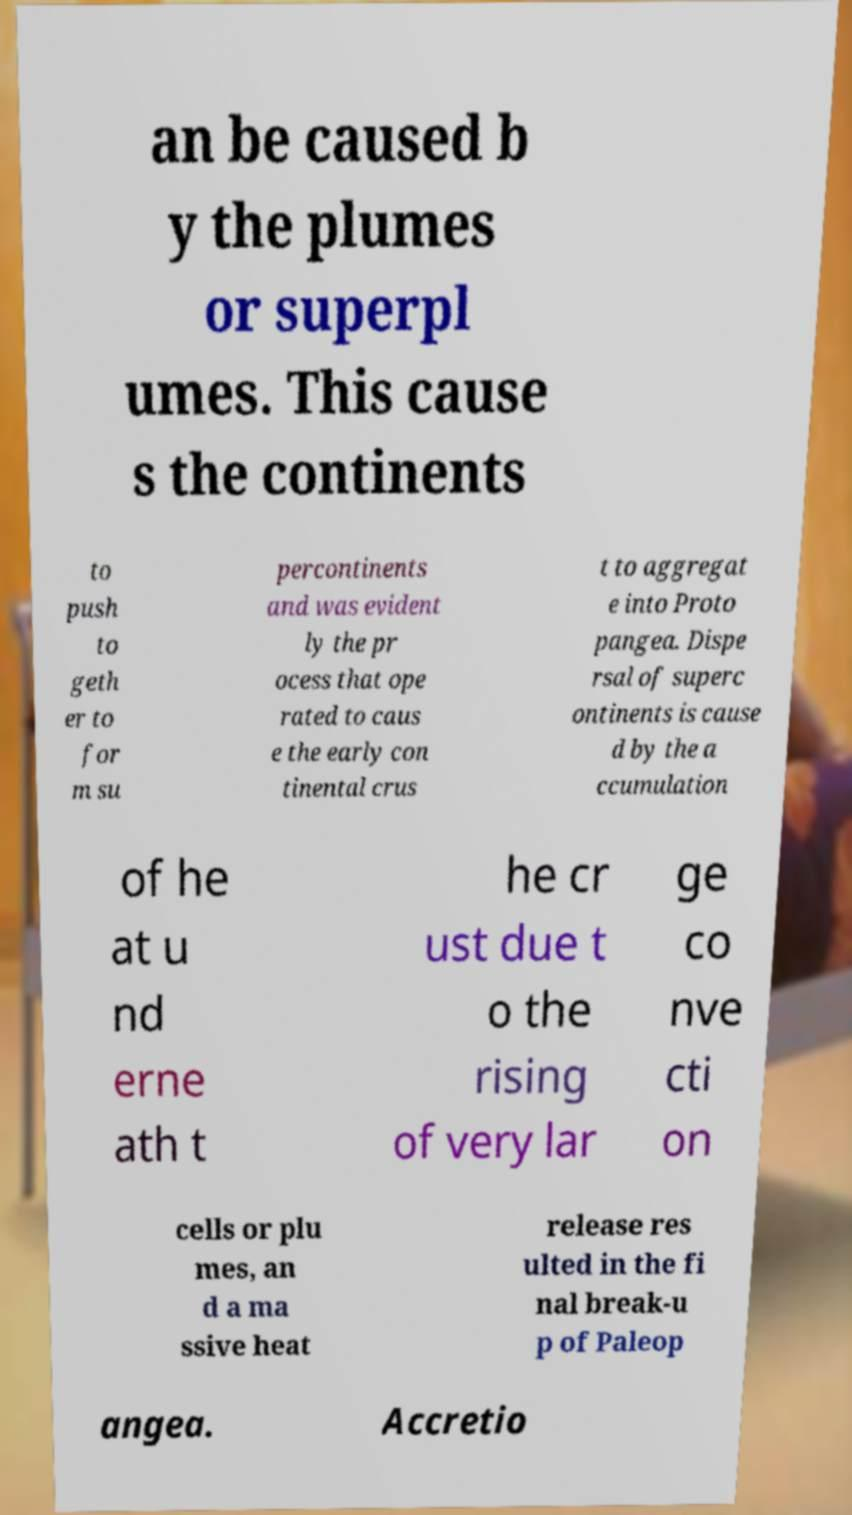Could you extract and type out the text from this image? an be caused b y the plumes or superpl umes. This cause s the continents to push to geth er to for m su percontinents and was evident ly the pr ocess that ope rated to caus e the early con tinental crus t to aggregat e into Proto pangea. Dispe rsal of superc ontinents is cause d by the a ccumulation of he at u nd erne ath t he cr ust due t o the rising of very lar ge co nve cti on cells or plu mes, an d a ma ssive heat release res ulted in the fi nal break-u p of Paleop angea. Accretio 